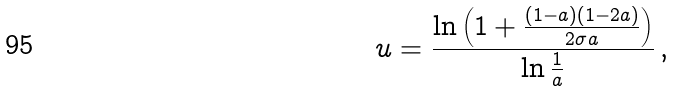Convert formula to latex. <formula><loc_0><loc_0><loc_500><loc_500>u = \frac { \ln { \left ( 1 + \frac { ( 1 - a ) ( 1 - 2 a ) } { 2 \sigma a } \right ) } } { \ln { \frac { 1 } { a } } } \, ,</formula> 